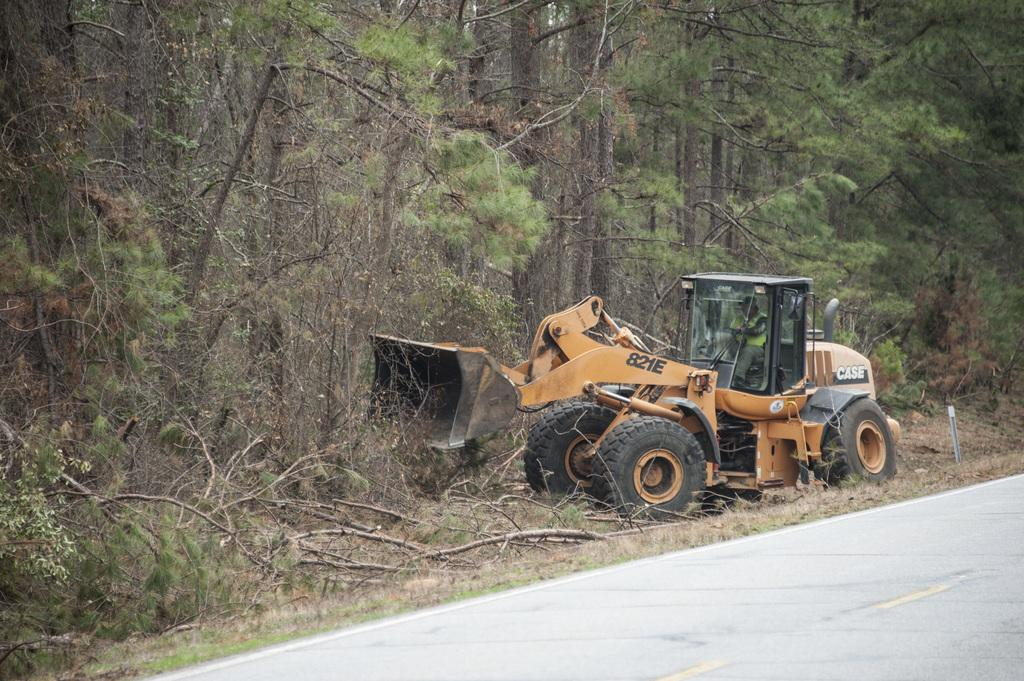<image>
Provide a brief description of the given image. A bulldozer marked with 821E on its side pushes tree branches off the road. 